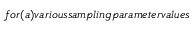Convert formula to latex. <formula><loc_0><loc_0><loc_500><loc_500>f o r ( a ) v a r i o u s s a m p l i n g p a r a m e t e r v a l u e s</formula> 